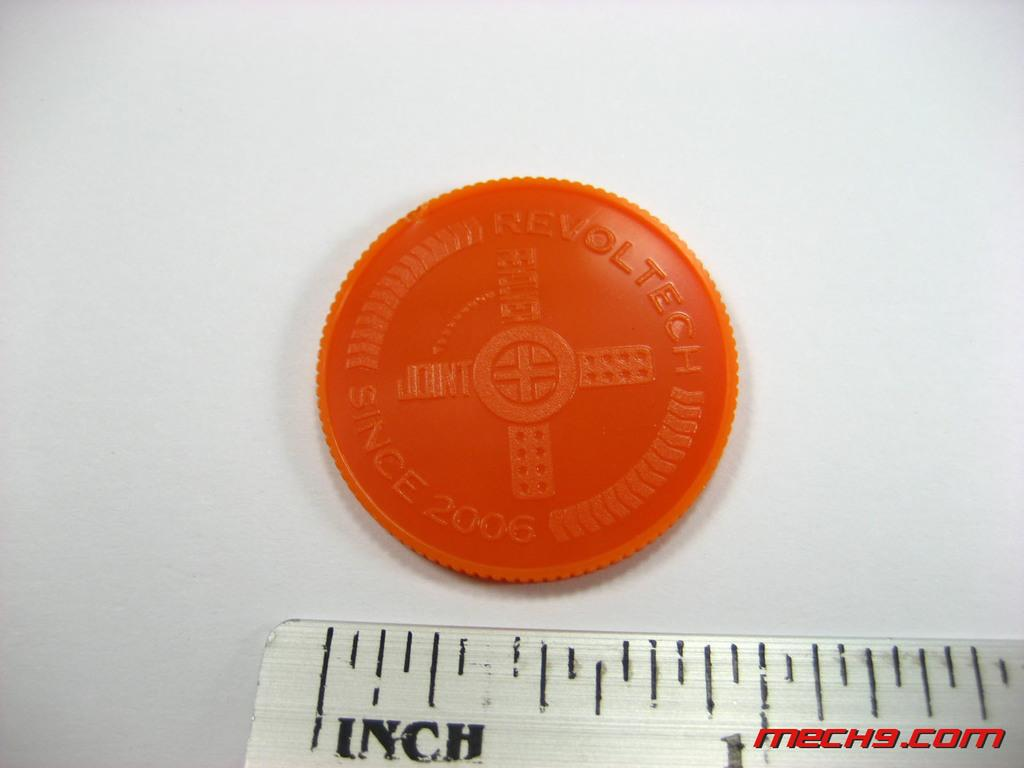<image>
Write a terse but informative summary of the picture. Red Revoltech is being measured by a ruler 